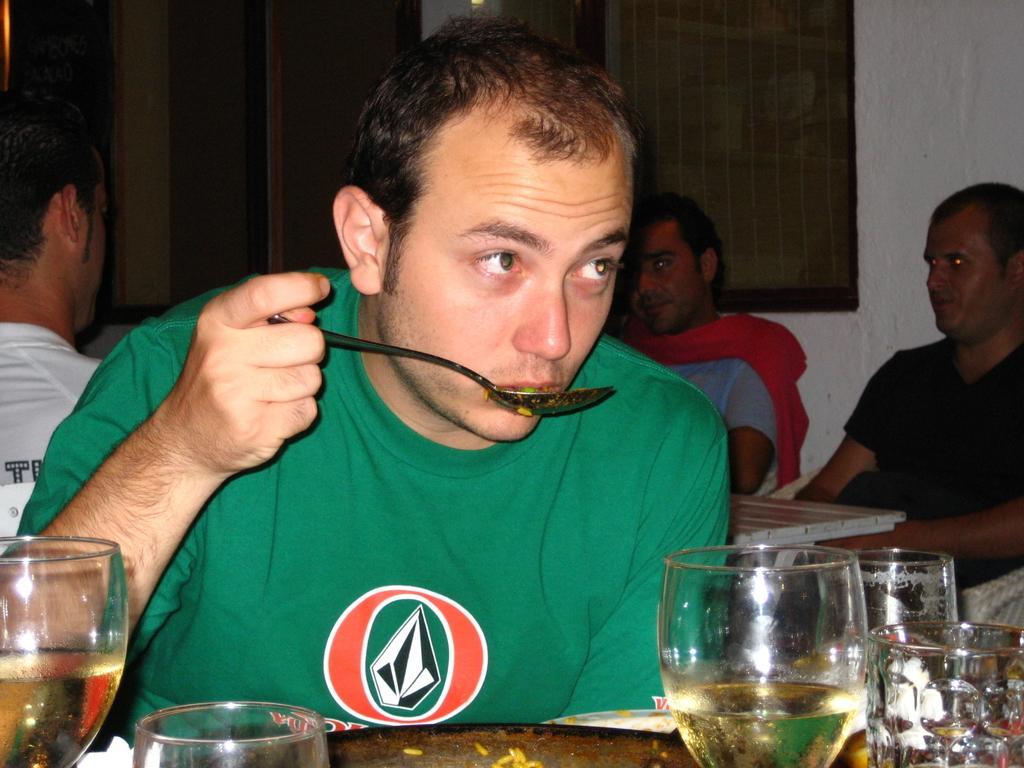How would you summarize this image in a sentence or two? In this picture we can see four persons sitting in front of tables, there are glasses on this table, this man is holding a spoon, in the background there is a wall. 